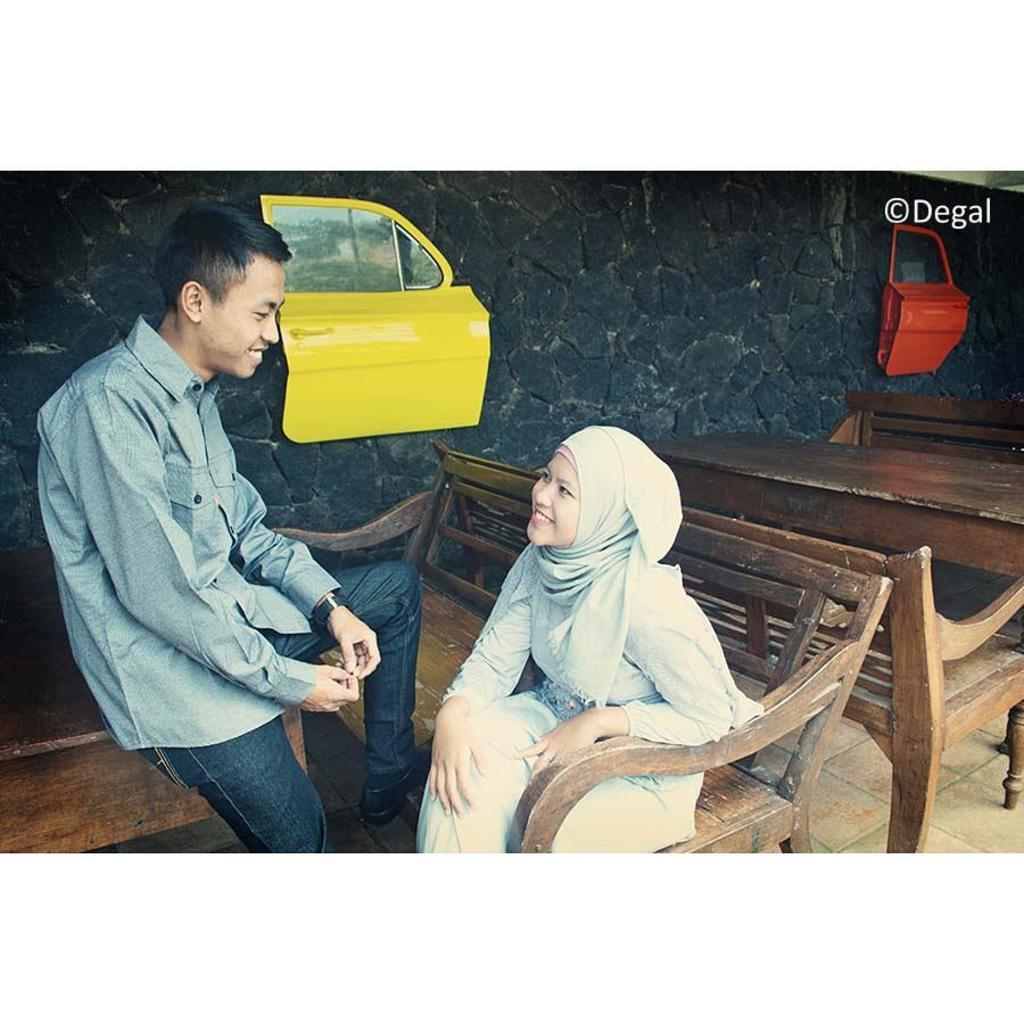What is the man in the image doing? The man is sitting on a table in the image. What is the woman in the image doing? The woman is sitting on a bench and talking in the image. What type of furniture can be seen in the image? Tables and benches are visible in the image. What else can be seen in the image besides the people and furniture? There are vehicle doors and a wall visible in the image. What type of glass is being used as a table in the image? There is no glass table present in the image; the man is sitting on a regular table. What is the downtown area like in the image? The image does not depict a downtown area; it only shows a man sitting on a table, a woman sitting on a bench and talking, furniture, vehicle doors, and a wall. 